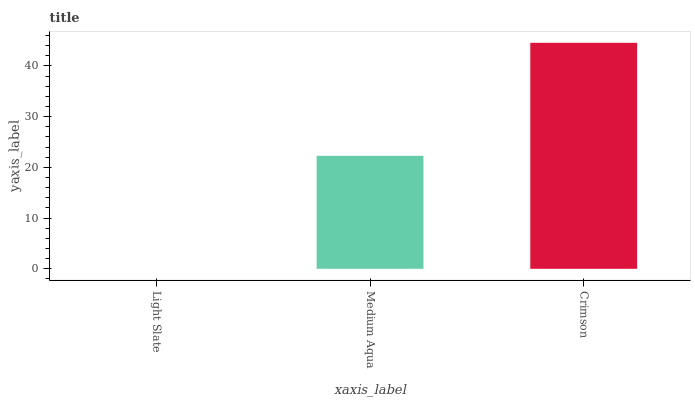Is Light Slate the minimum?
Answer yes or no. Yes. Is Crimson the maximum?
Answer yes or no. Yes. Is Medium Aqua the minimum?
Answer yes or no. No. Is Medium Aqua the maximum?
Answer yes or no. No. Is Medium Aqua greater than Light Slate?
Answer yes or no. Yes. Is Light Slate less than Medium Aqua?
Answer yes or no. Yes. Is Light Slate greater than Medium Aqua?
Answer yes or no. No. Is Medium Aqua less than Light Slate?
Answer yes or no. No. Is Medium Aqua the high median?
Answer yes or no. Yes. Is Medium Aqua the low median?
Answer yes or no. Yes. Is Crimson the high median?
Answer yes or no. No. Is Crimson the low median?
Answer yes or no. No. 